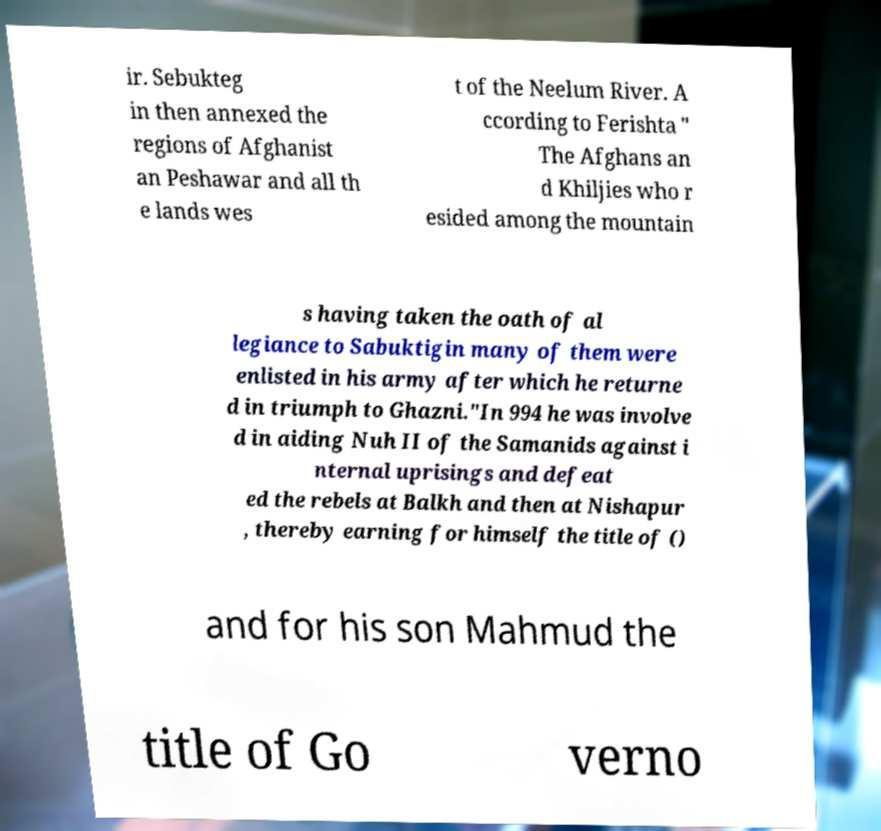Can you accurately transcribe the text from the provided image for me? ir. Sebukteg in then annexed the regions of Afghanist an Peshawar and all th e lands wes t of the Neelum River. A ccording to Ferishta " The Afghans an d Khiljies who r esided among the mountain s having taken the oath of al legiance to Sabuktigin many of them were enlisted in his army after which he returne d in triumph to Ghazni."In 994 he was involve d in aiding Nuh II of the Samanids against i nternal uprisings and defeat ed the rebels at Balkh and then at Nishapur , thereby earning for himself the title of () and for his son Mahmud the title of Go verno 